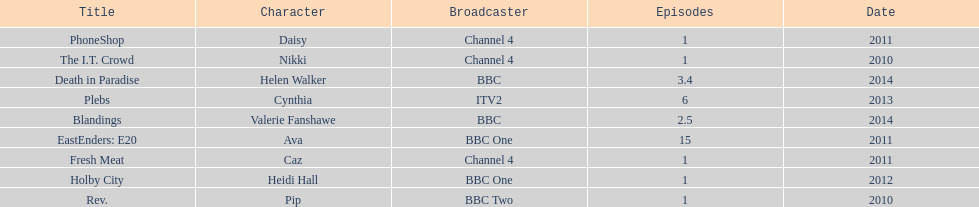What is the total number of shows sophie colguhoun appeared in? 9. 